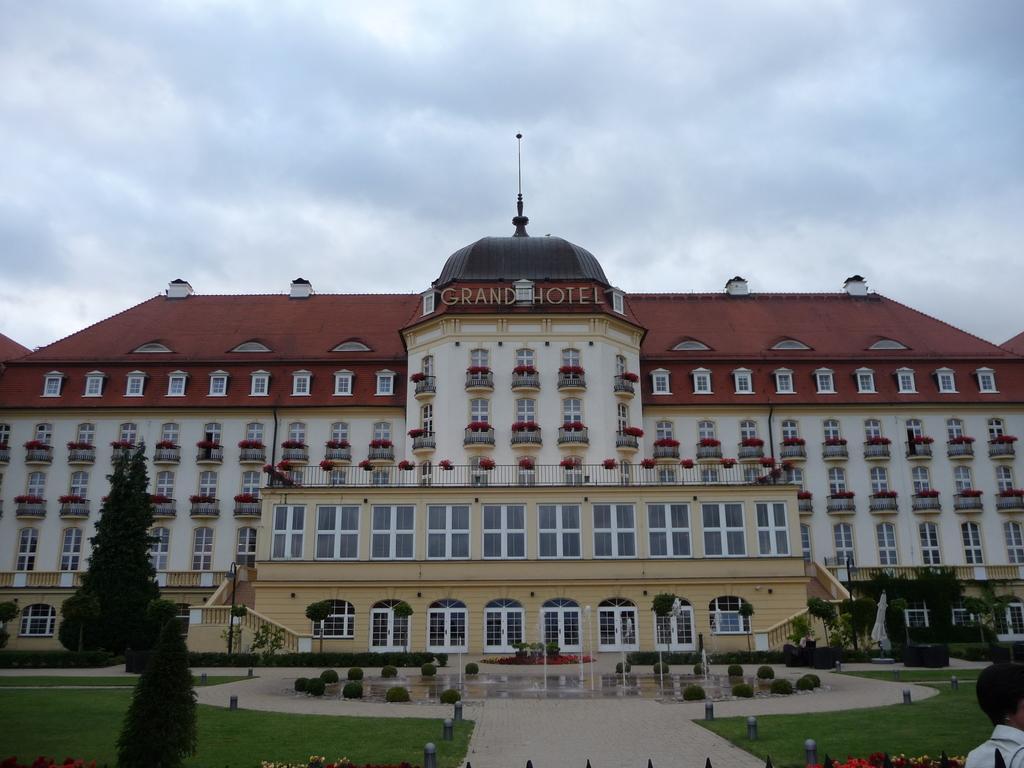Describe this image in one or two sentences. In the picture I can see a building which has windows. I can also see water fountain, the grass, plants, trees, poles and some other objects on the ground. In the background I can see the sky. 